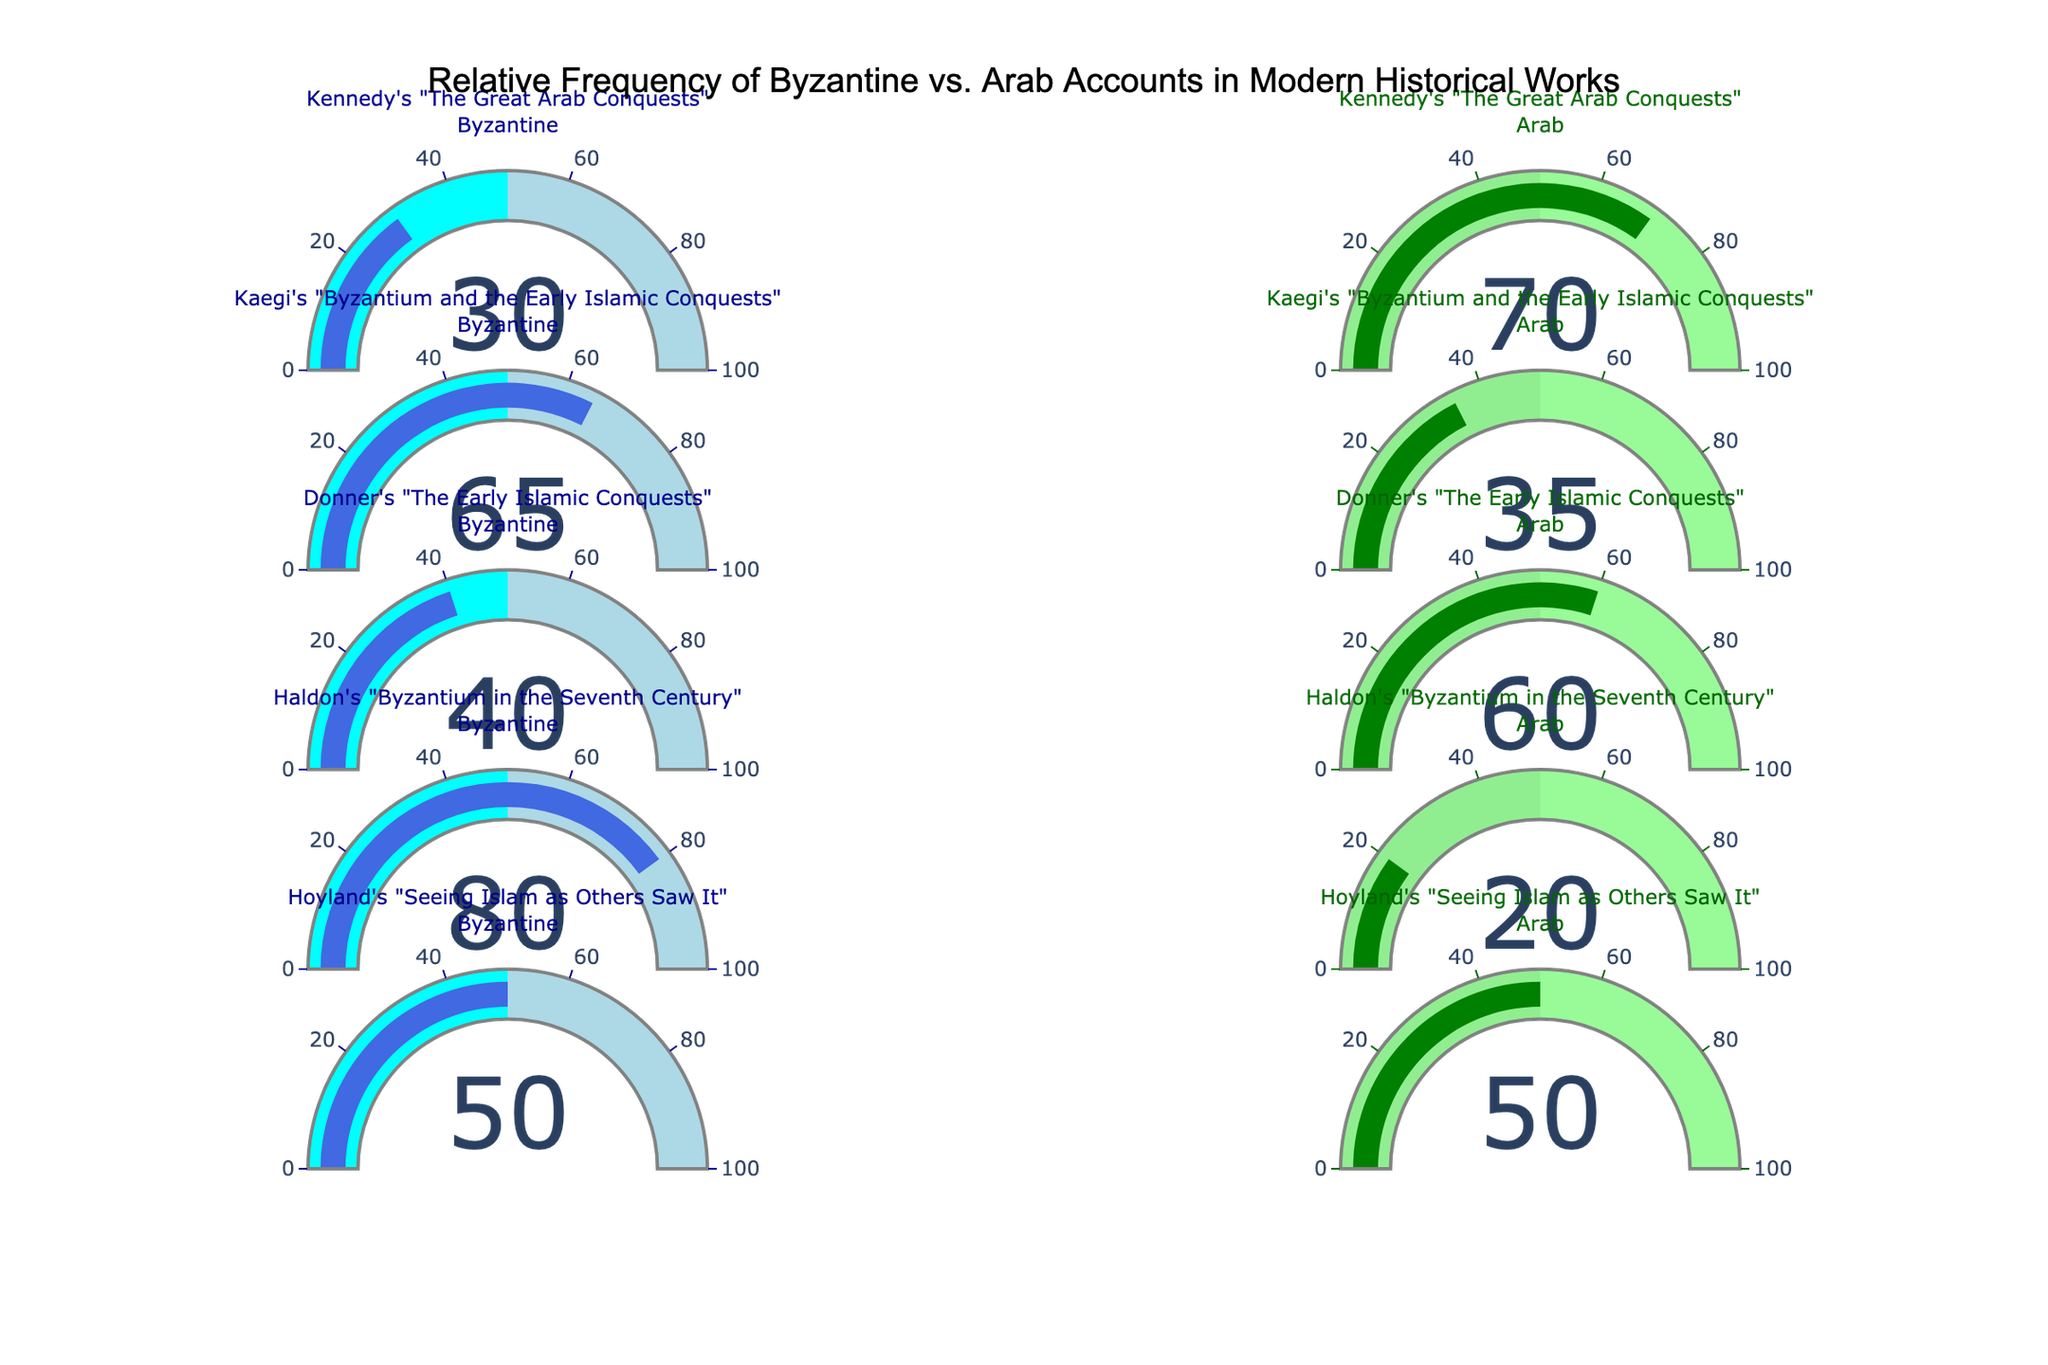How many historical works have a higher relative frequency of Arab accounts compared to Byzantine accounts? Review each gauge chart to identify which have a higher value for Arab accounts. Four books (Kennedy's, Donner's, and Hoyland's works have a higher frequency of Arab accounts and Hoyland's work has equal values) meet this criterion.
Answer: 4 works Which work has the greatest discrepancy between Byzantine and Arab accounts? Calculate the absolute difference between Byzantine and Arab accounts for each work. The greatest discrepancy is found in Haldon's work; the difference is 80 - 20 = 60.
Answer: Haldon's work What is the average frequency of Byzantine accounts across all works? Add the values of Byzantine accounts from all the works ((30 + 65 + 40 + 80 + 50) = 265) and divide by the number of works (265 / 5).
Answer: 53 Which historical work shows an equal usage of Byzantine and Arab accounts? Identify the gauge chart with equal values for both types of accounts. Hoyland's work has 50 Byzantine and 50 Arab accounts.
Answer: Hoyland's work Comparing Kennedy's and Kaegi's works, which one cites Arab accounts more frequently? Compare the values given for Arab accounts in Kennedy's work (70) and Kaegi's work (35). Kennedy's work has a higher frequency.
Answer: Kennedy's work What's the median value of Arab accounts in the listed historical works? List the Arab account values in increasing order: 20, 35, 50, 60, 70. The median value is the middle number in this ordered list.
Answer: 50 Which historical work has the lowest frequency of Arab accounts? Compare the Arab account values for all works and find the lowest value. Haldon's work cites Arab accounts the least frequently, at 20.
Answer: Haldon's work What is the sum of Byzantine accounts cited in the works of Donner and Hoyland? Add the Byzantine account values for Donner's (40) and Hoyland's (50) works. (40 + 50 = 90)
Answer: 90 By how much does Kaegi's citation of Byzantine accounts exceed Kennedy's? Subtract Kennedy's frequency of Byzantine accounts (30) from Kaegi's (65). (65 - 30 = 35)
Answer: 35 How many works cite Byzantine accounts less than 50%? Count the works where the value of Byzantine accounts is less than 50 (Kennedy's 30, Donner's 40, Hoyland's 50). Only two works have less than 50% Byzantine accounts.
Answer: 2 works 